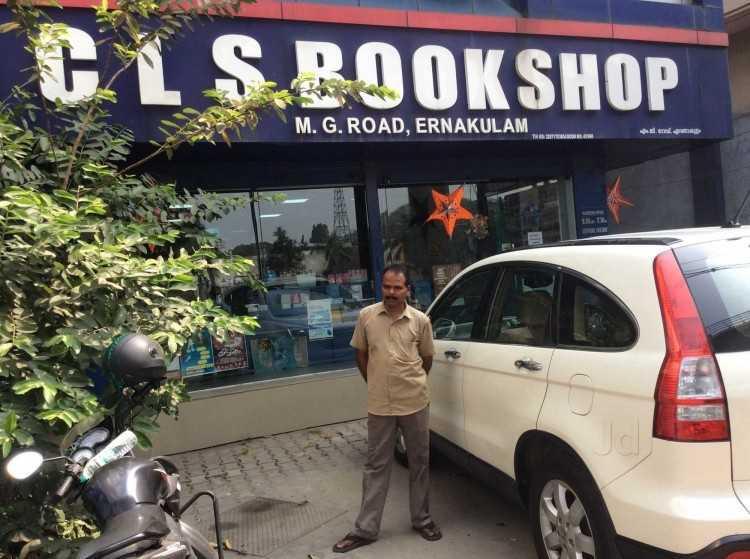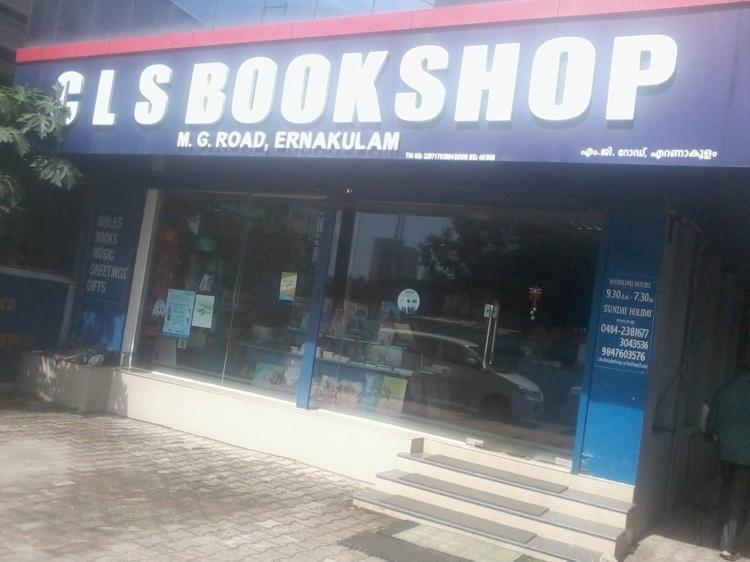The first image is the image on the left, the second image is the image on the right. For the images shown, is this caption "At least one image shows a bookshop that uses royal blue in its color scheme." true? Answer yes or no. Yes. The first image is the image on the left, the second image is the image on the right. Given the left and right images, does the statement "There are two bookstores, with bright light visible through the windows of at least one." hold true? Answer yes or no. No. 